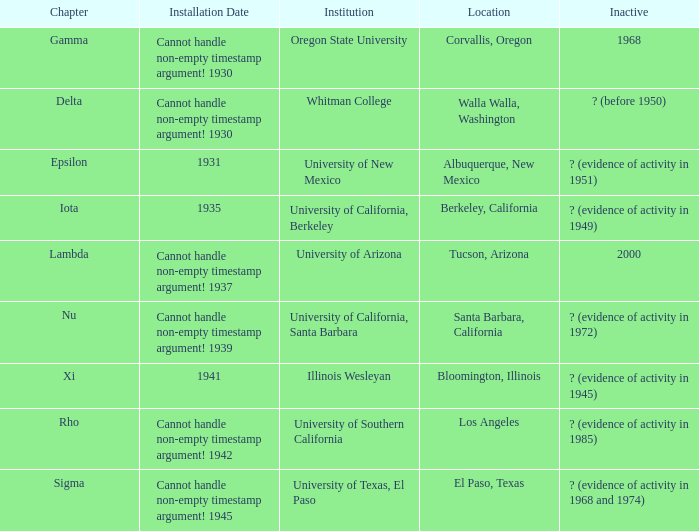What was the setup date in el paso, texas? Cannot handle non-empty timestamp argument! 1945. 